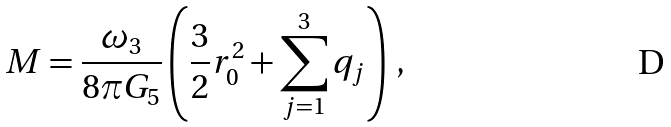<formula> <loc_0><loc_0><loc_500><loc_500>M = \frac { \omega _ { 3 } } { 8 \pi G _ { 5 } } \left ( \frac { 3 } { 2 } r _ { 0 } ^ { 2 } + \sum _ { j = 1 } ^ { 3 } q _ { j } \right ) \, ,</formula> 